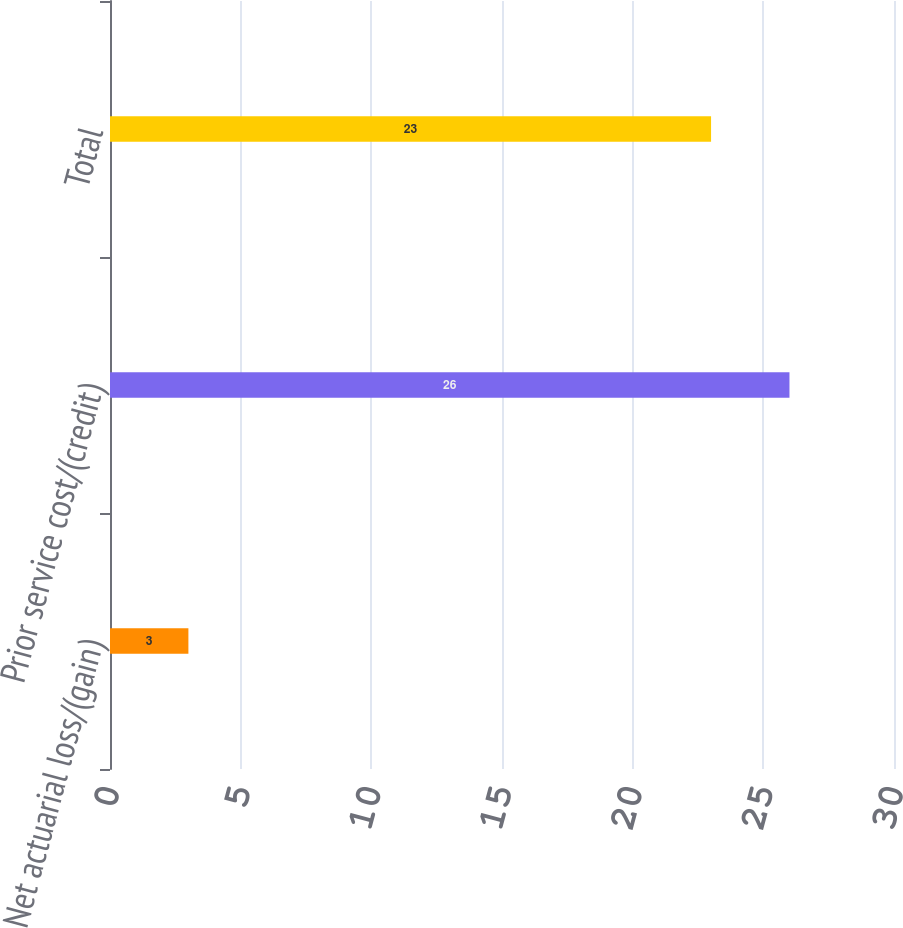Convert chart to OTSL. <chart><loc_0><loc_0><loc_500><loc_500><bar_chart><fcel>Net actuarial loss/(gain)<fcel>Prior service cost/(credit)<fcel>Total<nl><fcel>3<fcel>26<fcel>23<nl></chart> 